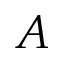Convert formula to latex. <formula><loc_0><loc_0><loc_500><loc_500>A</formula> 